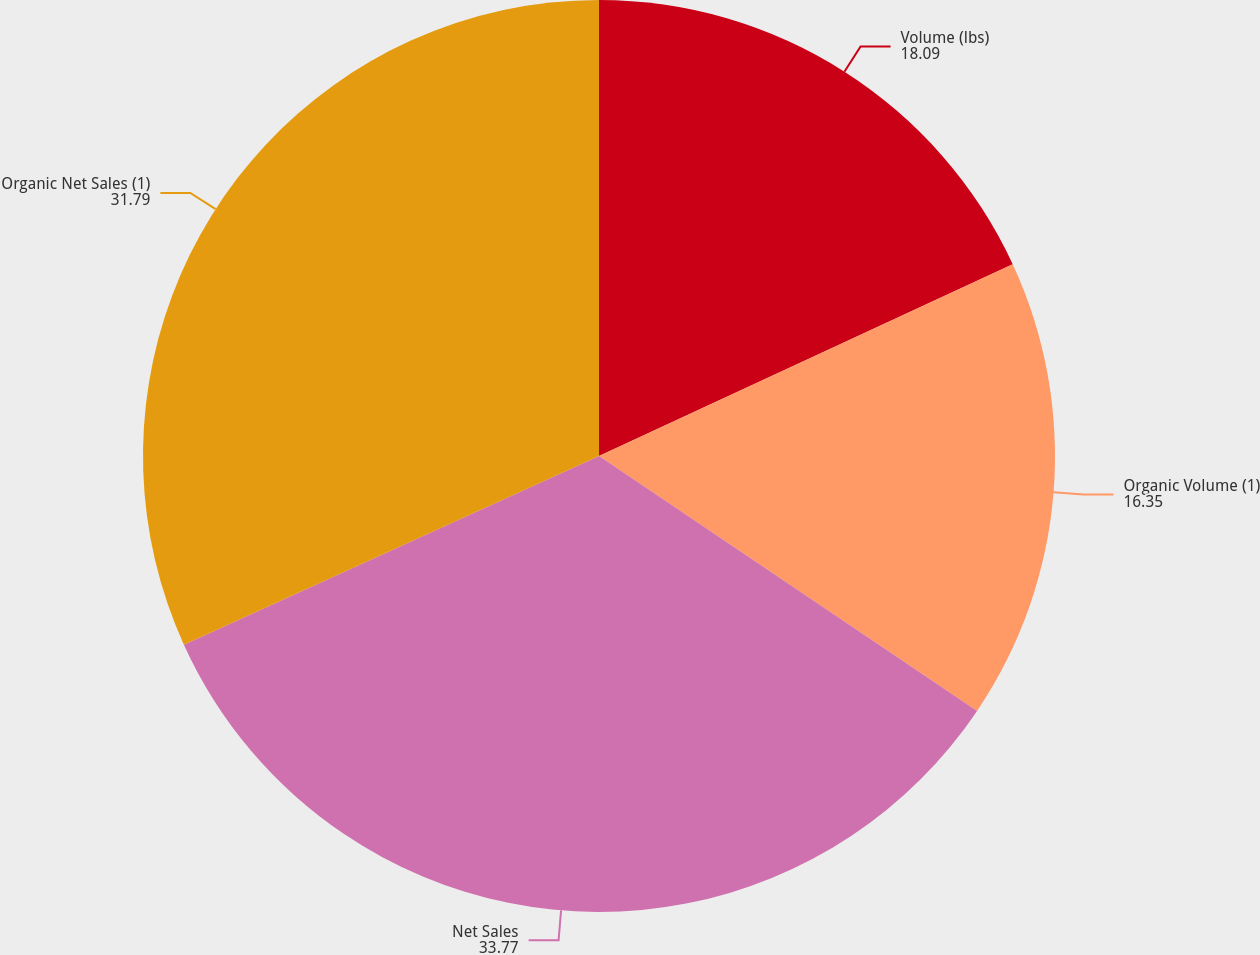<chart> <loc_0><loc_0><loc_500><loc_500><pie_chart><fcel>Volume (lbs)<fcel>Organic Volume (1)<fcel>Net Sales<fcel>Organic Net Sales (1)<nl><fcel>18.09%<fcel>16.35%<fcel>33.77%<fcel>31.79%<nl></chart> 